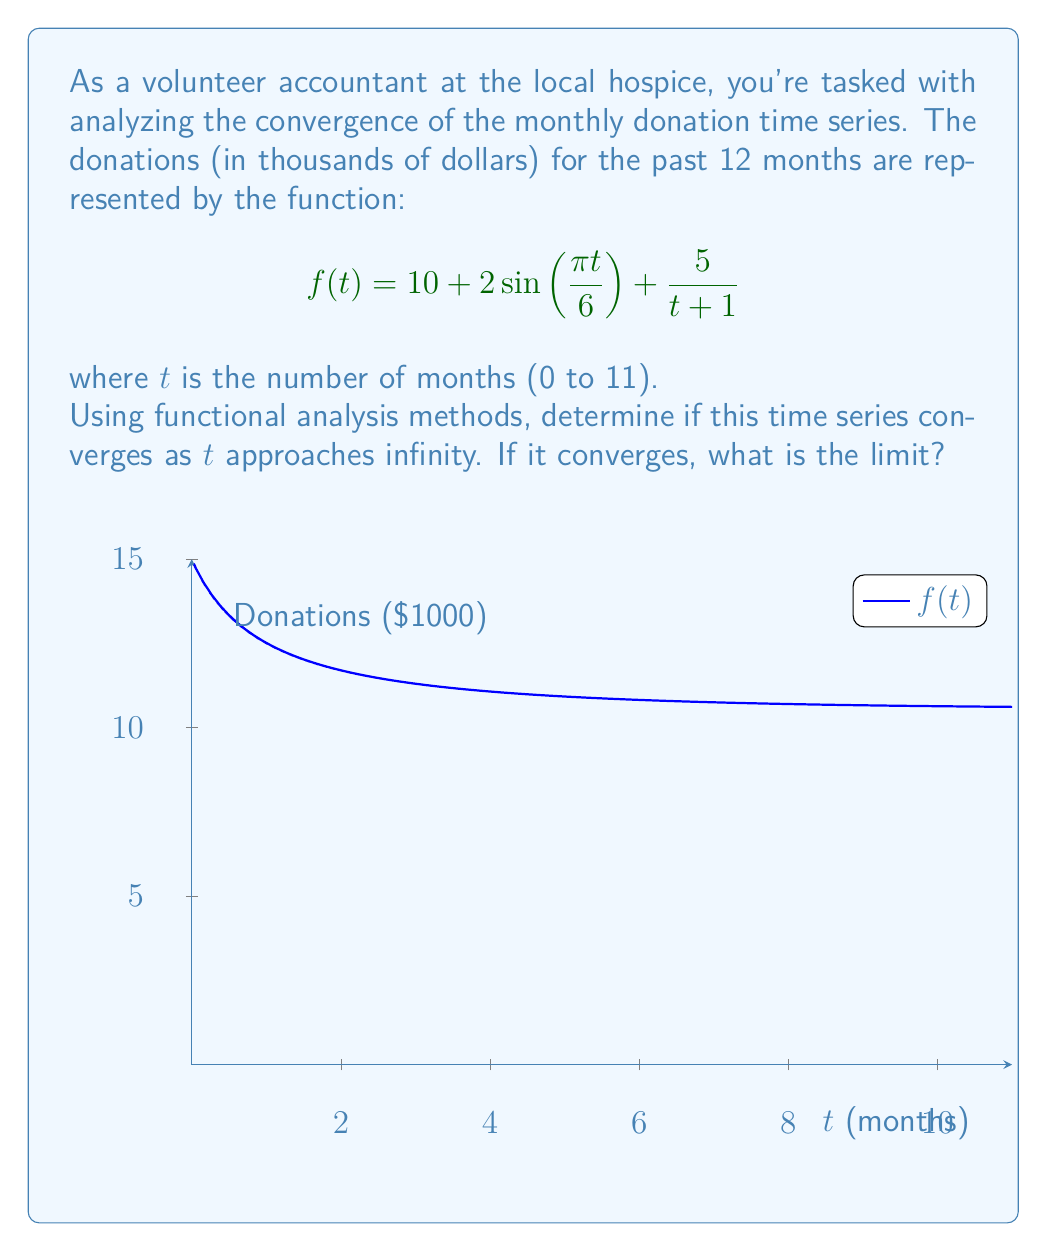Show me your answer to this math problem. To analyze the convergence of this time series using functional methods, we'll follow these steps:

1) First, let's break down the function into its components:
   $$f(t) = 10 + 2\sin(\frac{\pi t}{6}) + \frac{5}{t+1}$$

2) As $t$ approaches infinity, we need to consider the limit of each component:

   a) The constant term: $\lim_{t \to \infty} 10 = 10$

   b) The sinusoidal term: $\lim_{t \to \infty} 2\sin(\frac{\pi t}{6})$ 
      This doesn't have a limit as it oscillates between -2 and 2 indefinitely.

   c) The rational term: $\lim_{t \to \infty} \frac{5}{t+1} = 0$
      As $t$ grows, this term approaches 0.

3) Combining these results:
   $$\lim_{t \to \infty} f(t) = 10 + 2\sin(\frac{\pi t}{6}) + 0$$

4) The presence of the sinusoidal term prevents the function from converging to a single value. Instead, it will oscillate around 10 with an amplitude of 2.

5) In functional analysis terms, this function doesn't converge in the usual sense, but it does have a limit superior and limit inferior:

   $\limsup_{t \to \infty} f(t) = 12$
   $\liminf_{t \to \infty} f(t) = 8$

6) We can say that the function converges to a limit cycle, oscillating between 8 and 12 as $t$ approaches infinity.
Answer: The time series does not converge to a single value but converges to a limit cycle oscillating between 8 and 12. 